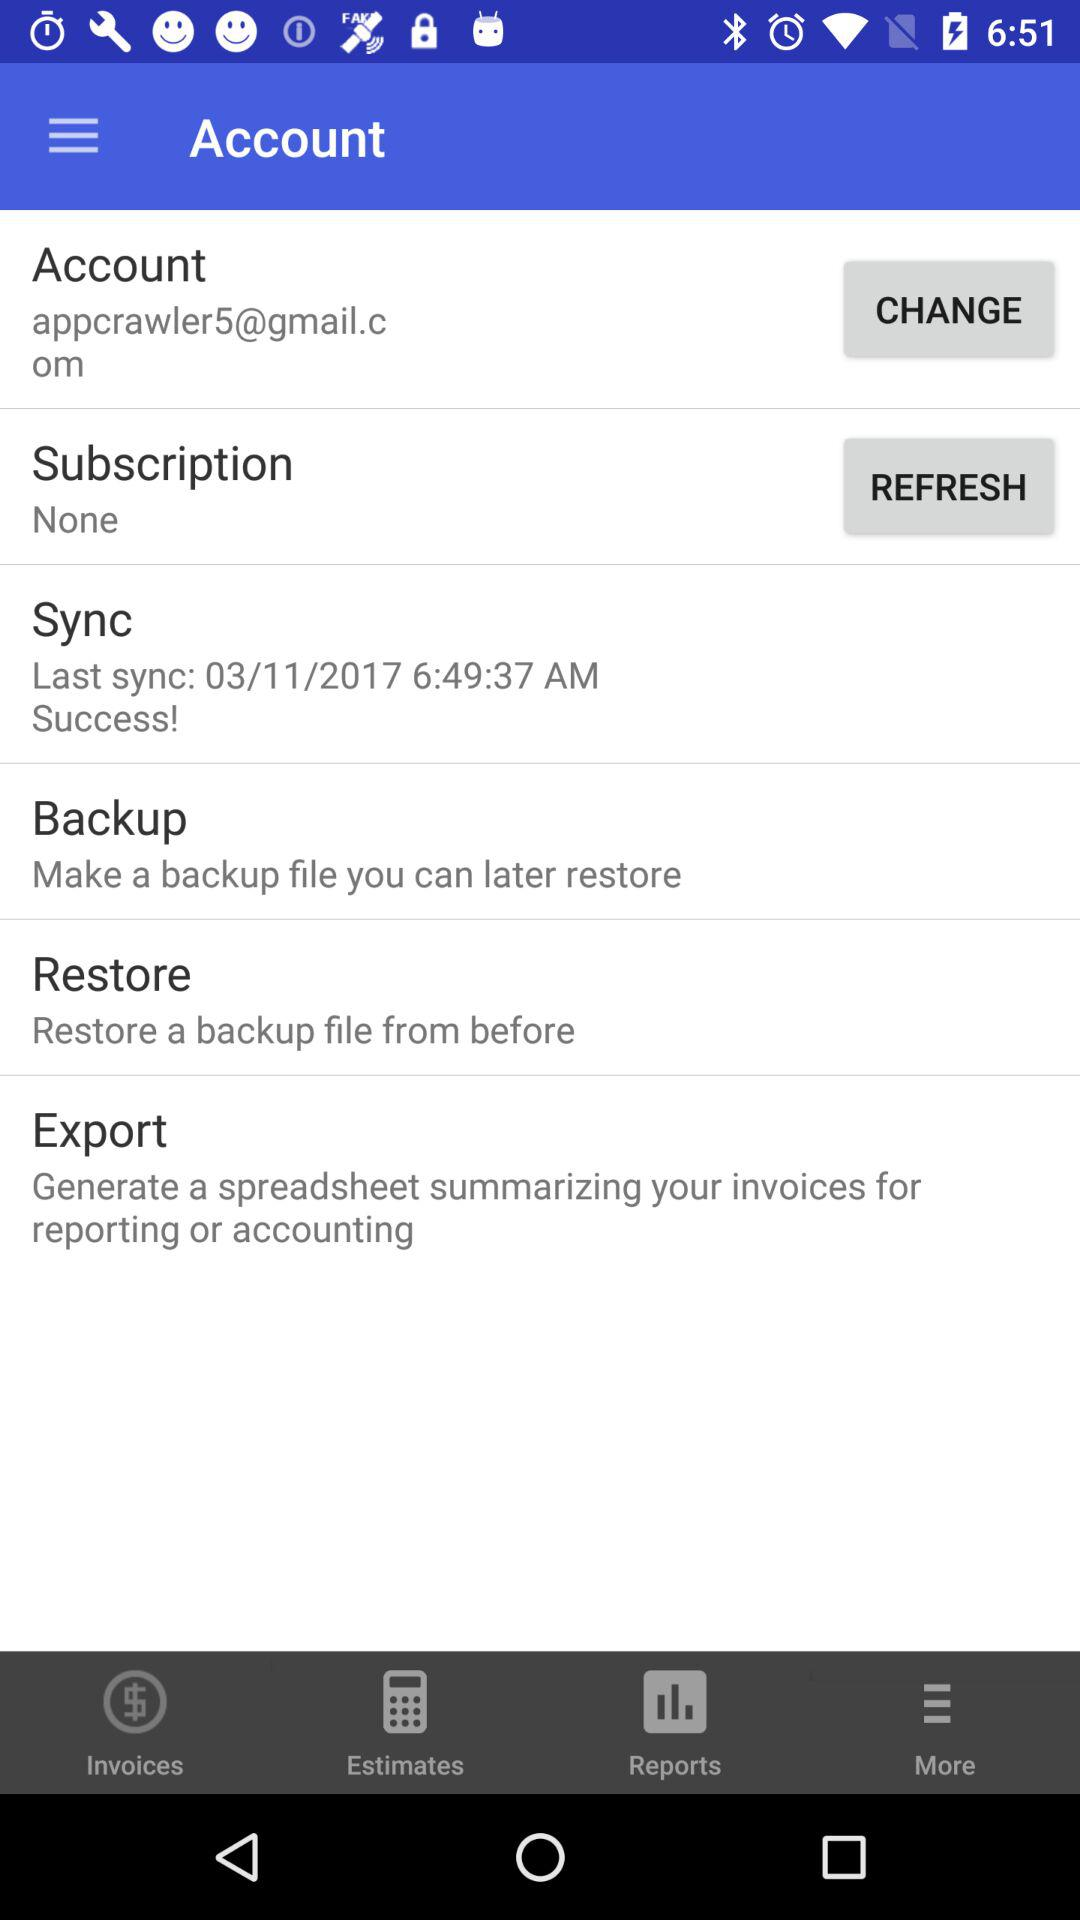What is the given email address? The given email address is appcrawler5@gmail.com. 